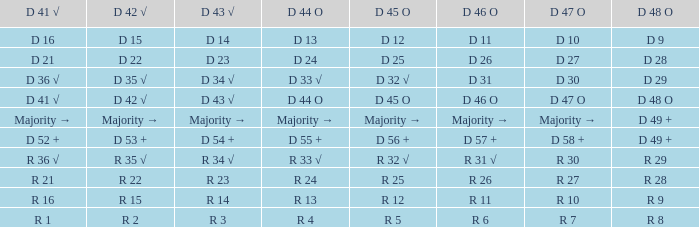Specify the d 45 o having d 44 o majority. Majority →. Parse the table in full. {'header': ['D 41 √', 'D 42 √', 'D 43 √', 'D 44 O', 'D 45 O', 'D 46 O', 'D 47 O', 'D 48 O'], 'rows': [['D 16', 'D 15', 'D 14', 'D 13', 'D 12', 'D 11', 'D 10', 'D 9'], ['D 21', 'D 22', 'D 23', 'D 24', 'D 25', 'D 26', 'D 27', 'D 28'], ['D 36 √', 'D 35 √', 'D 34 √', 'D 33 √', 'D 32 √', 'D 31', 'D 30', 'D 29'], ['D 41 √', 'D 42 √', 'D 43 √', 'D 44 O', 'D 45 O', 'D 46 O', 'D 47 O', 'D 48 O'], ['Majority →', 'Majority →', 'Majority →', 'Majority →', 'Majority →', 'Majority →', 'Majority →', 'D 49 +'], ['D 52 +', 'D 53 +', 'D 54 +', 'D 55 +', 'D 56 +', 'D 57 +', 'D 58 +', 'D 49 +'], ['R 36 √', 'R 35 √', 'R 34 √', 'R 33 √', 'R 32 √', 'R 31 √', 'R 30', 'R 29'], ['R 21', 'R 22', 'R 23', 'R 24', 'R 25', 'R 26', 'R 27', 'R 28'], ['R 16', 'R 15', 'R 14', 'R 13', 'R 12', 'R 11', 'R 10', 'R 9'], ['R 1', 'R 2', 'R 3', 'R 4', 'R 5', 'R 6', 'R 7', 'R 8']]} 